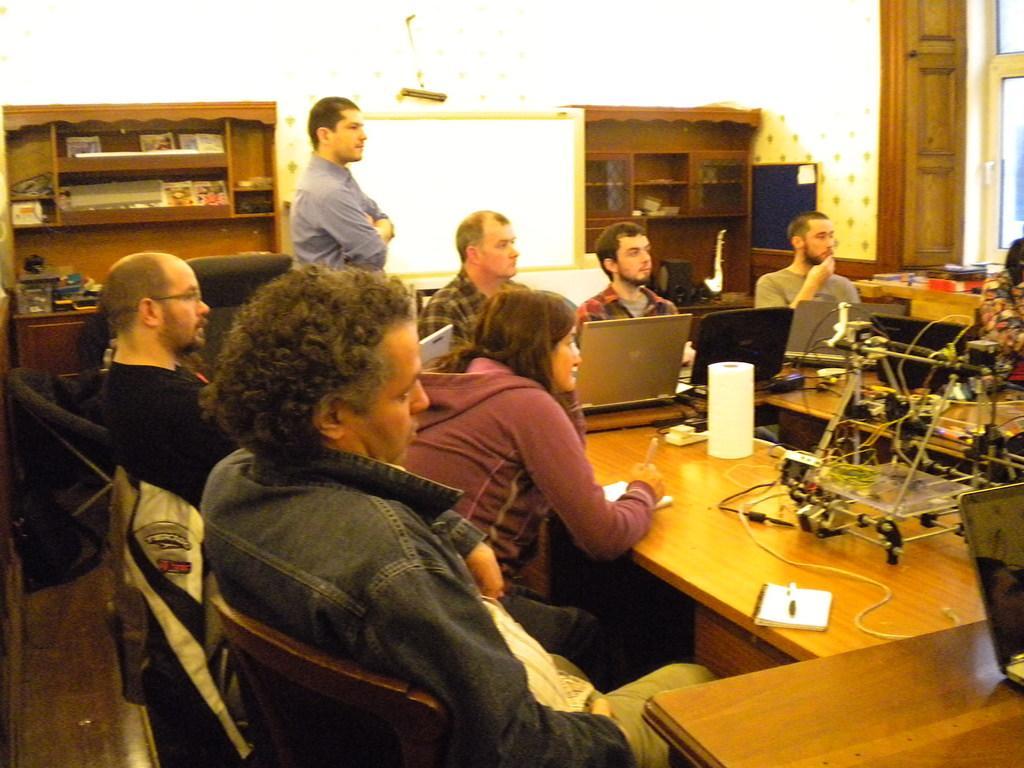Please provide a concise description of this image. Here we can see some persons are sitting on the chairs. This is table. On the table there are laptops, and a book. Here we can see a man who is standing on the floor. This is screen and there is a door. 